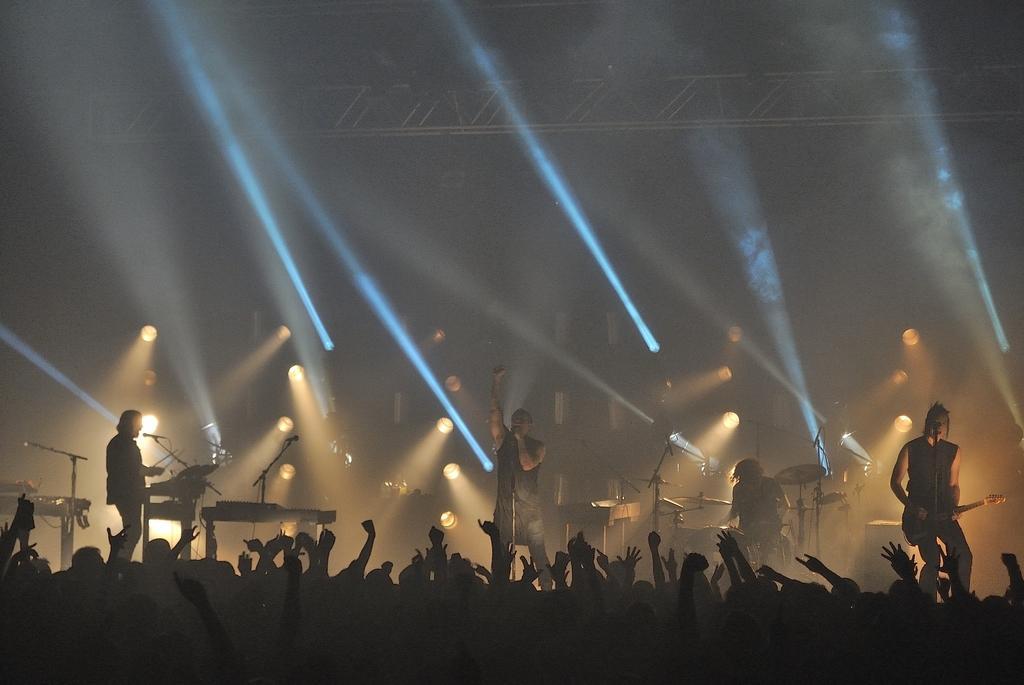In one or two sentences, can you explain what this image depicts? In this image, we can see a rock band. There is a crowd at the bottom of the image. There are some persons playing musical instruments. There are lights in the middle of the image. There is a metal frame at the top of the image. 